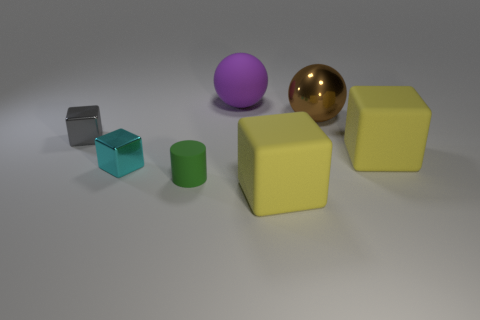Is the color of the rubber sphere the same as the rubber object that is to the right of the metal ball?
Offer a terse response. No. What color is the matte object that is both behind the small green cylinder and in front of the large brown sphere?
Keep it short and to the point. Yellow. There is a green object; how many small gray cubes are behind it?
Your answer should be compact. 1. What number of things are either small gray matte blocks or things in front of the large brown metal object?
Provide a succinct answer. 5. There is a big purple rubber ball right of the small cyan metal thing; are there any big shiny spheres that are in front of it?
Your answer should be compact. Yes. What is the color of the large cube that is in front of the cyan shiny block?
Offer a terse response. Yellow. Is the number of yellow rubber objects behind the big matte ball the same as the number of big green shiny cubes?
Ensure brevity in your answer.  Yes. There is a big thing that is both in front of the brown ball and behind the cyan cube; what is its shape?
Offer a very short reply. Cube. There is a large shiny object that is the same shape as the purple rubber object; what is its color?
Offer a terse response. Brown. Are there any other things that have the same color as the tiny matte cylinder?
Offer a very short reply. No. 